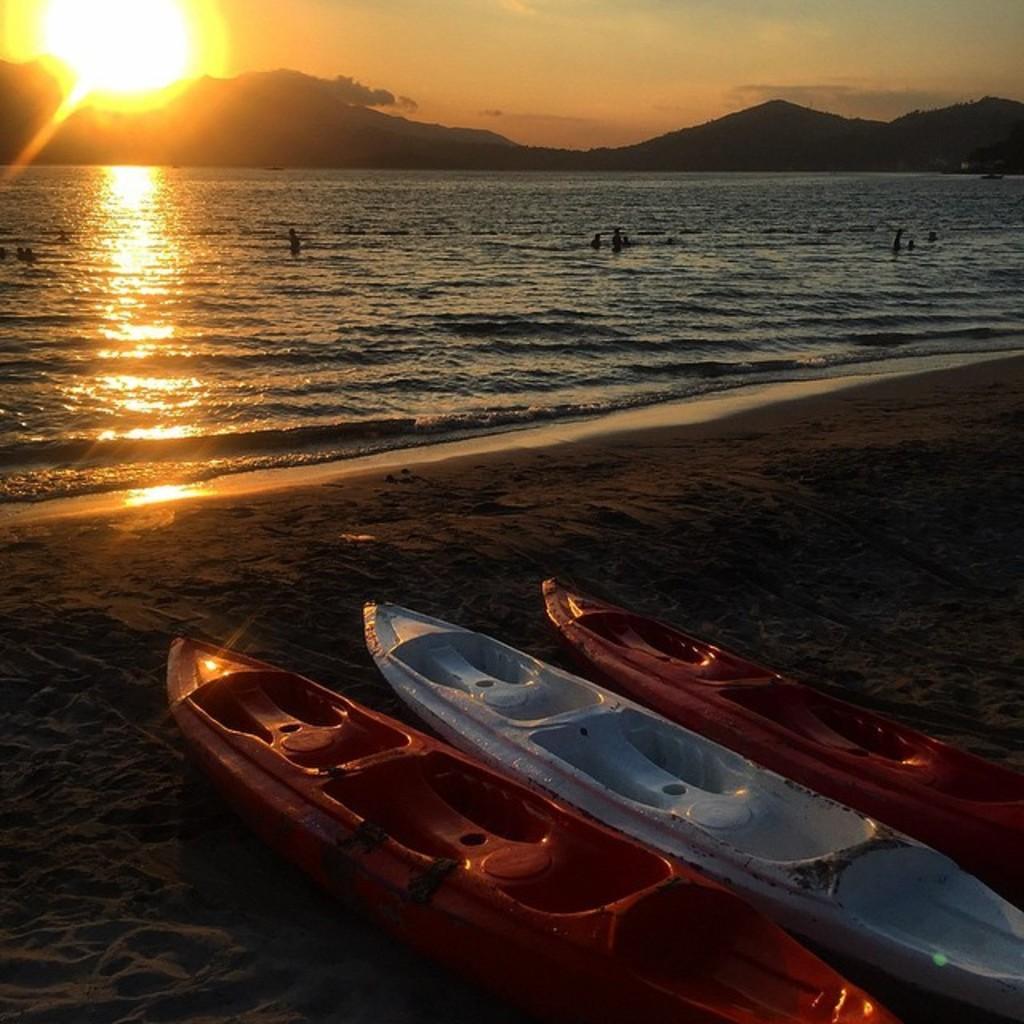Please provide a concise description of this image. In the picture we can see a sand surface, on it we can see some boats which are red and blue in color and near to it there is a water and in the background we can see some hills, sky and sunshine. 